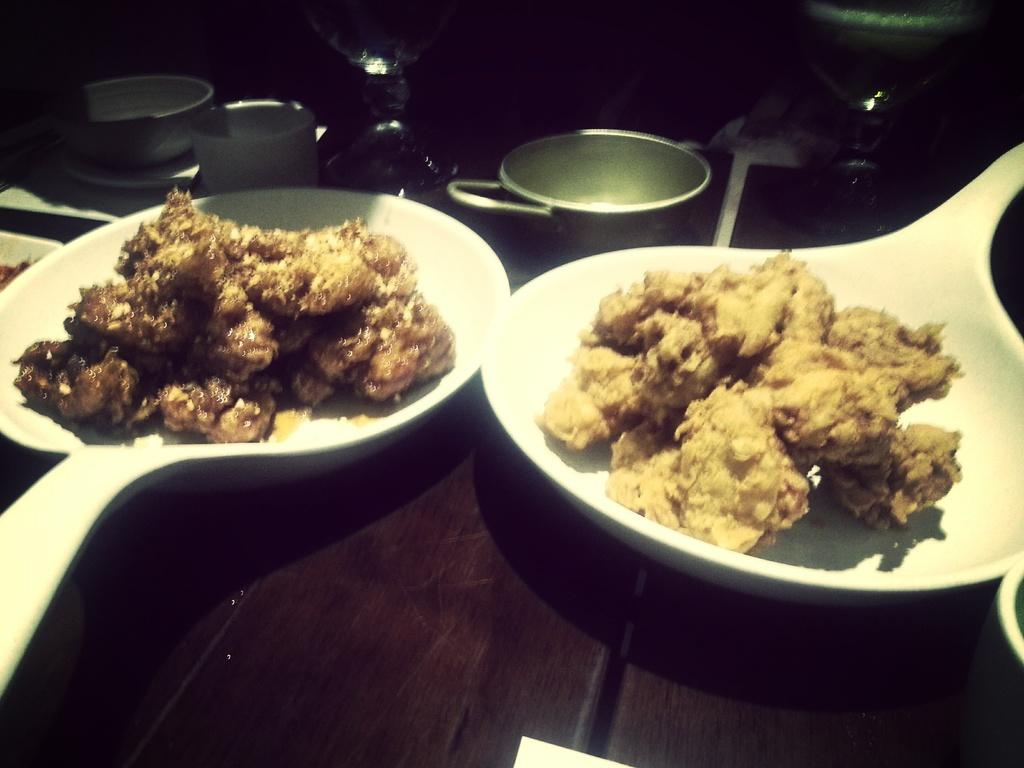What type of utensils can be seen in the image? There are two white spoons in the image. What is on the spoons? There is food on the spoons. How many oranges are being kissed in the image? There are no oranges or any indication of kissing in the image. 